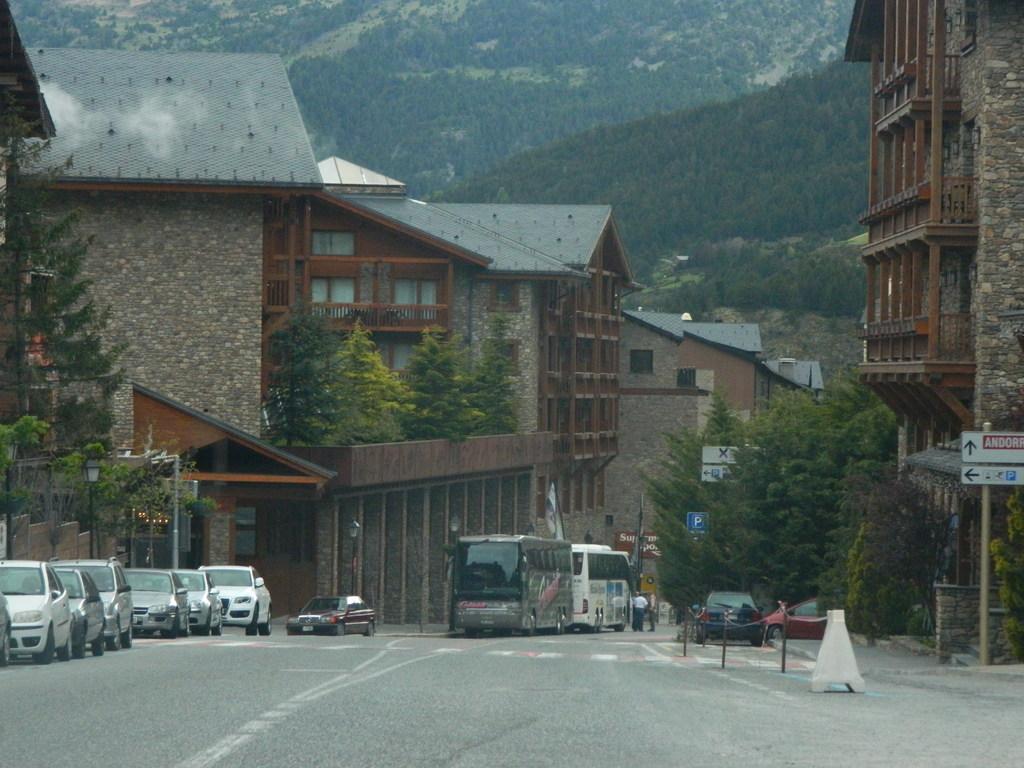How would you summarize this image in a sentence or two? In this image we can see the mountains, some houses, some boards with text attached to the poles, one white safety pole on the road, some people standing on the road, some vehicles on the road, one flag attached to the pole, some vehicles parked, some lights attached to the poles, one metal barrier with chain on the road, some trees, bushes, plants and grass on the ground. 